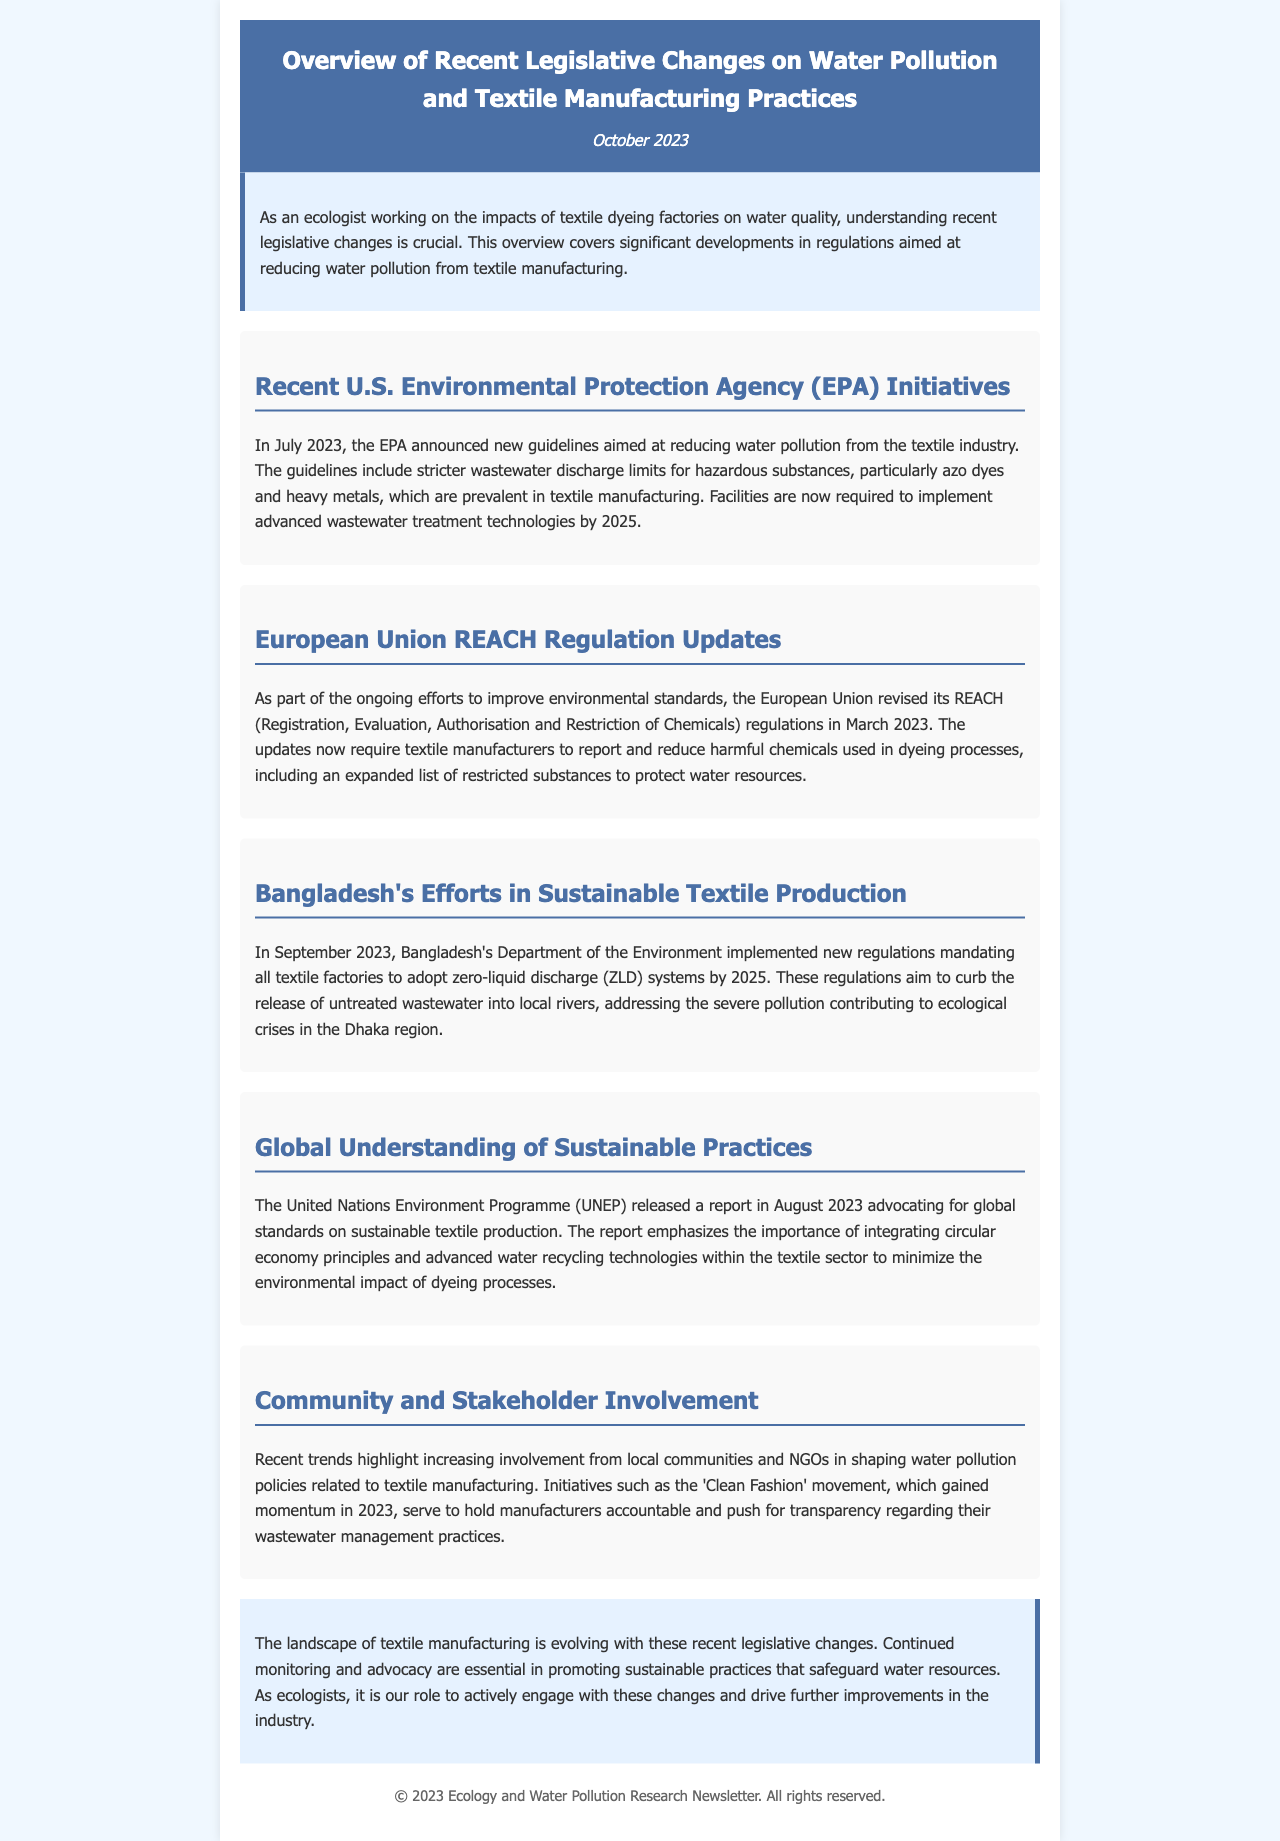What are the new guidelines announced by the EPA? The EPA announced new guidelines aimed at reducing water pollution from the textile industry.
Answer: New guidelines When did the EU revise its REACH regulations? The document states that the European Union revised its REACH regulations in March 2023.
Answer: March 2023 What is mandated by Bangladesh's new regulations for textile factories? The regulations mandate all textile factories to adopt zero-liquid discharge systems by 2025.
Answer: Zero-liquid discharge systems Which organization's report advocates for global standards in sustainable textile production? The United Nations Environment Programme (UNEP) released the report advocating for global standards.
Answer: United Nations Environment Programme What significant movement gained momentum in 2023? The 'Clean Fashion' movement gained momentum in 2023.
Answer: Clean Fashion What is the deadline for textile factories to implement advanced wastewater treatment technologies in the U.S.? Facilities are required to implement advanced wastewater treatment technologies by 2025.
Answer: 2025 What is a key aim of the EU's revised REACH regulations? The key aim of the updates is to report and reduce harmful chemicals used in dyeing processes.
Answer: Report and reduce harmful chemicals What phrase describes the importance of the UNEP's report regarding the textile sector? The report emphasizes the importance of integrating circular economy principles.
Answer: Circular economy principles 